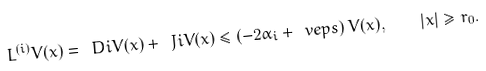Convert formula to latex. <formula><loc_0><loc_0><loc_500><loc_500>L ^ { ( i ) } V ( x ) = \ D i V ( x ) + \ J i V ( x ) \leq \left ( - 2 \alpha _ { i } + \ v e p s \right ) V ( x ) , \quad | x | \geq r _ { 0 } .</formula> 